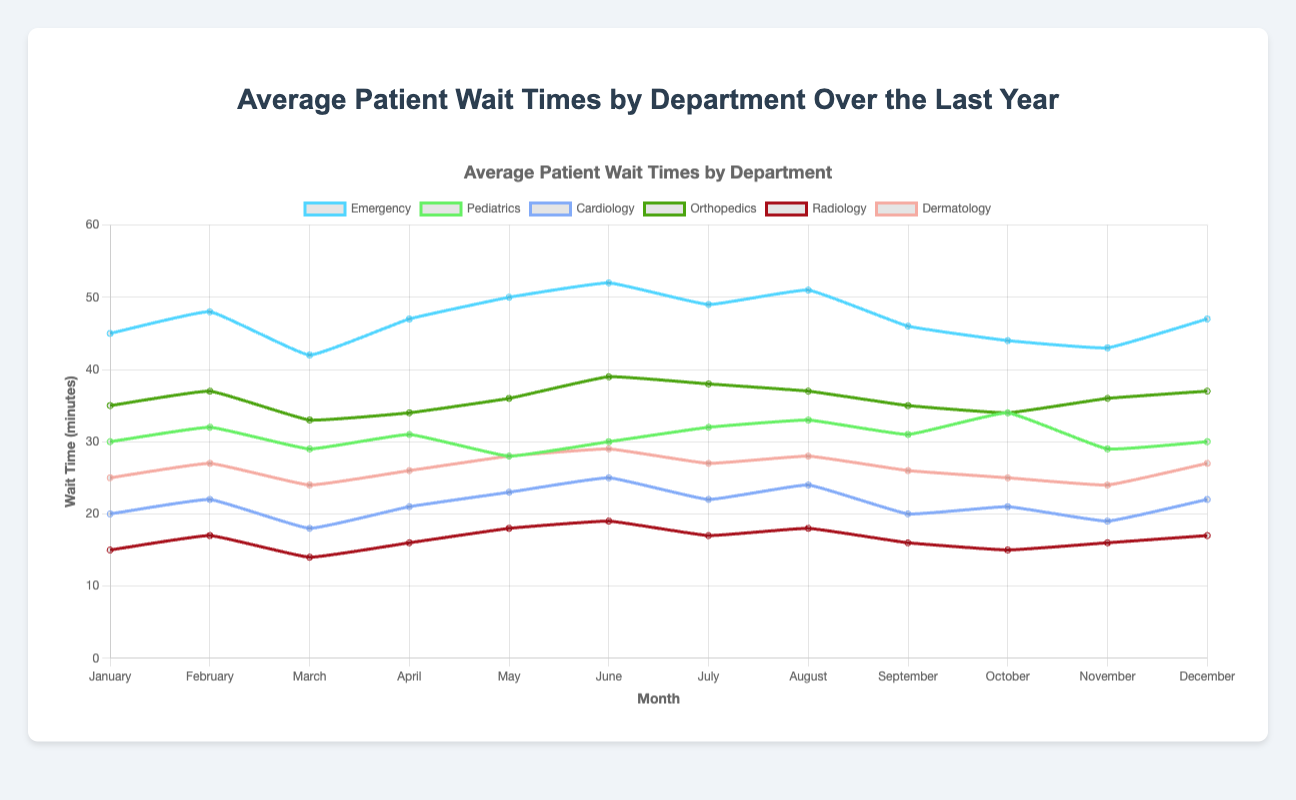What department had the highest average wait time in June? To determine the highest average wait time in June, we need to compare the wait times of each department for that month. From the data: Emergency (52 min), Pediatrics (30 min), Cardiology (25 min), Orthopedics (39 min), Radiology (19 min), Dermatology (29 min). Emergency department has the highest wait time.
Answer: Emergency Which month had the lowest wait time for Radiology? Look at the wait times for Radiology across all months and find the lowest value. From the data: January (15 min), February (17 min), March (14 min), April (16 min), May (18 min), June (19 min), July (17 min), August (18 min), September (16 min), October (15 min), November (16 min), December (17 min). The lowest wait time is in March (14 min).
Answer: March Between which months did the Emergency department see the largest decrease in wait times? To find the largest decrease, calculate the difference in wait times between consecutive months for the Emergency department and identify the pair with the largest negative difference. From the data: January to February (+3 min), February to March (-6 min), March to April (+5 min), April to May (+3 min), May to June (+2 min), June to July (-3 min), July to August (+2 min), August to September (-5 min), September to October (-2 min), October to November (-1 min), November to December (+4 min). The largest decrease is from February to March (-6 min).
Answer: February to March What is the overall average wait time for Pediatrics across the year? To find the overall average, sum up all monthly wait times for Pediatrics and divide by 12. From the data: (30 + 32 + 29 + 31 + 28 + 30 + 32 + 33 + 31 + 34 + 29 + 30) = 369. Average = 369 / 12 = 30.75 minutes.
Answer: 30.75 minutes How did the wait time for Dermatology in August compare to the wait time in February? Compare the wait times for Dermatology in February and August. From the data: February (27 min) and August (28 min). The wait time in August is 1 minute longer than in February.
Answer: 1 minute longer Which department consistently had the lowest wait times throughout the year? Identify the department with generally lower wait times each month by finding the minimum wait times for each month and noting the department. From the data, Radiology consistently has the lowest values compared to other departments.
Answer: Radiology What was the average wait time for Orthopedics from June to August? Calculate the average for Orthopedics for June, July, and August. From the data: (June (39) + July (38) + August (37)) = 114. Average = 114 / 3 = 38 minutes.
Answer: 38 minutes Is there any month where Cardiology had a wait time equal to or lower than 20 minutes? Check Cardiology's data for any month with wait times 20 min or less. From the data: March (18 min), September (20 min), November (19 min). Yes, March, September, and November meet the criteria.
Answer: Yes, March, September, and November Which department had the most stable (least variation) waiting times throughout the year? Determine the department with the smallest range of wait times (highest wait time - lowest wait time). From the data, calculate the range: Emergency (52-42=10), Pediatrics (34-28=6), Cardiology (25-18=7), Orthopedics (39-33=6), Radiology (19-14=5), Dermatology (29-24=5). The most stable wait times are for Dermatology and Radiology.
Answer: Dermatology and Radiology 